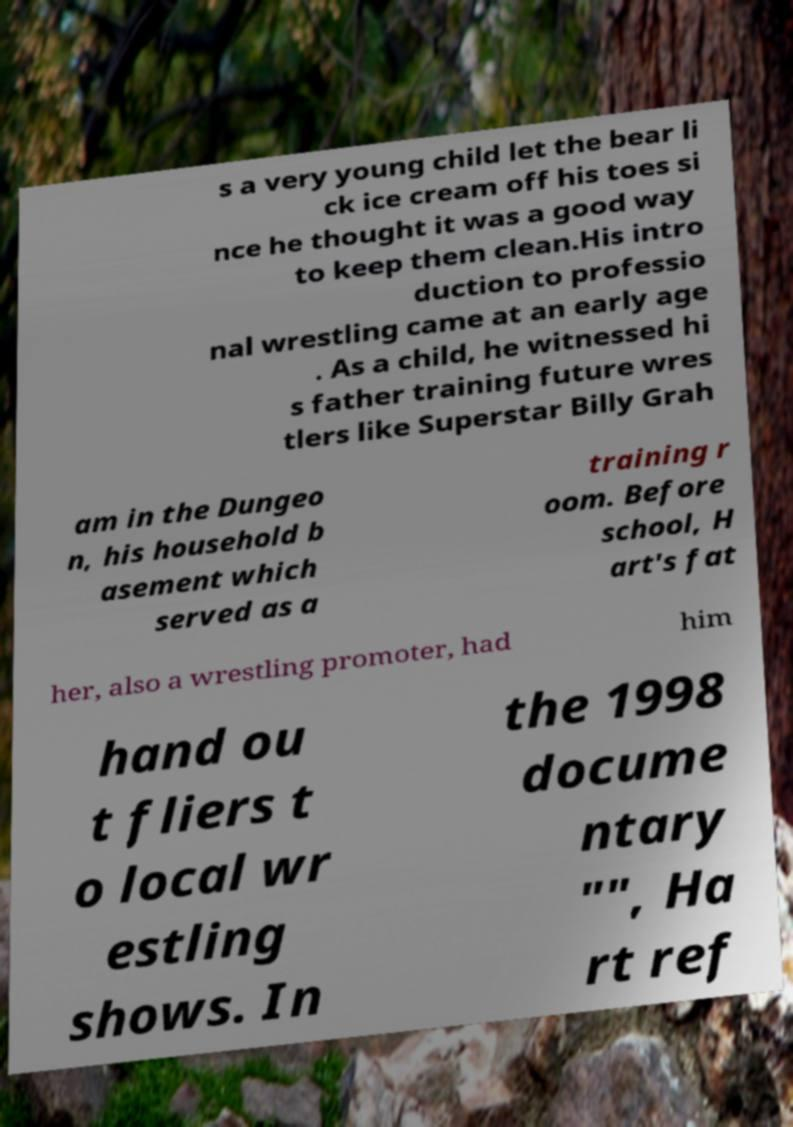Please identify and transcribe the text found in this image. s a very young child let the bear li ck ice cream off his toes si nce he thought it was a good way to keep them clean.His intro duction to professio nal wrestling came at an early age . As a child, he witnessed hi s father training future wres tlers like Superstar Billy Grah am in the Dungeo n, his household b asement which served as a training r oom. Before school, H art's fat her, also a wrestling promoter, had him hand ou t fliers t o local wr estling shows. In the 1998 docume ntary "", Ha rt ref 